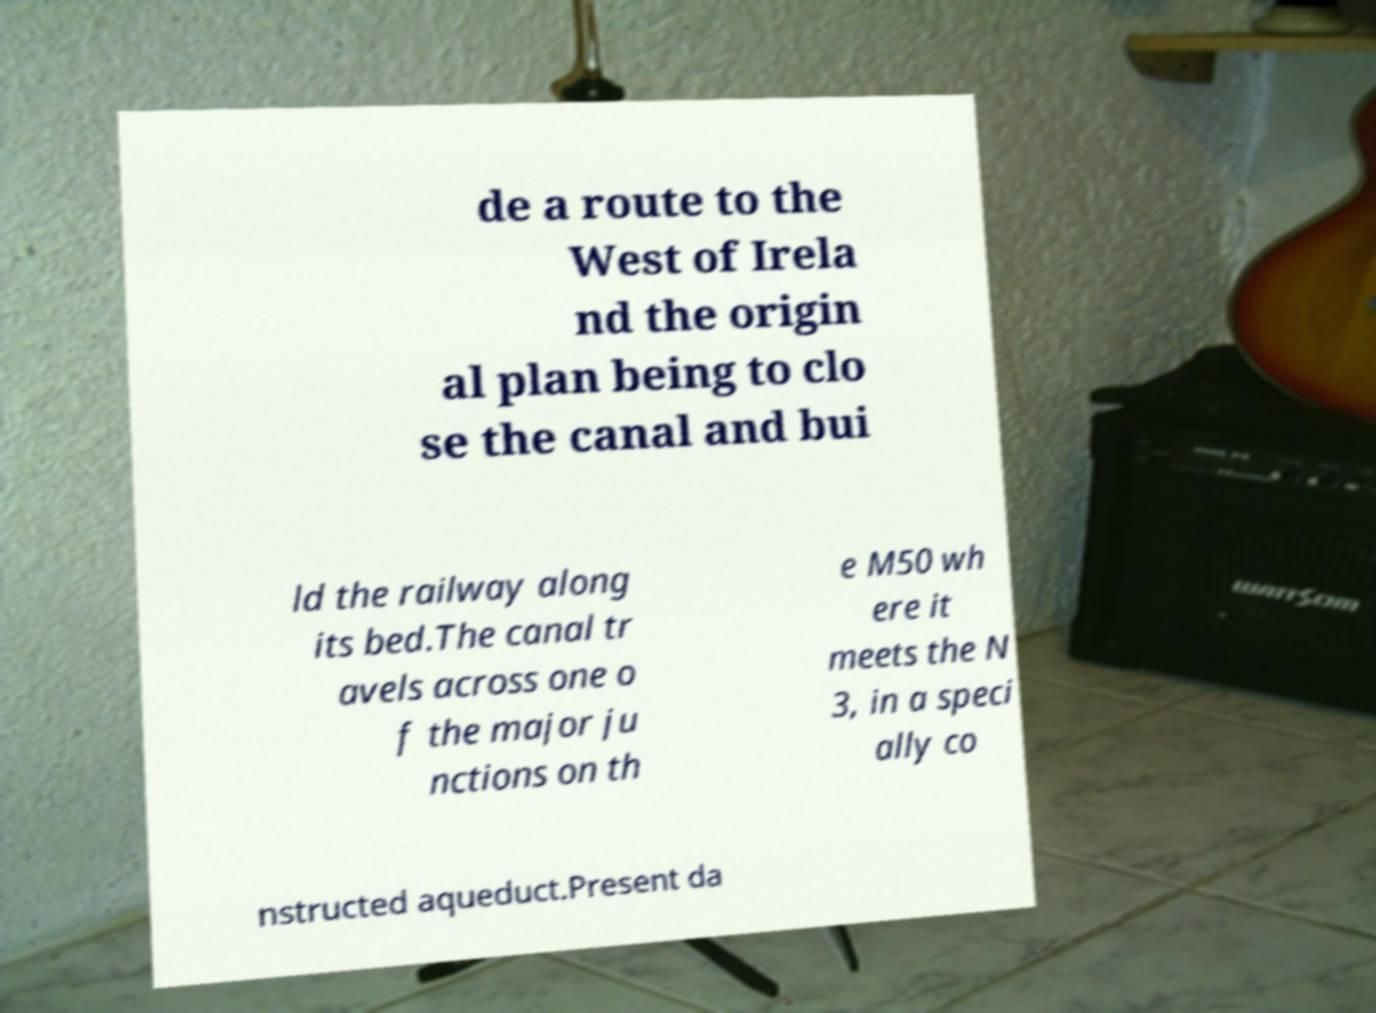Could you extract and type out the text from this image? de a route to the West of Irela nd the origin al plan being to clo se the canal and bui ld the railway along its bed.The canal tr avels across one o f the major ju nctions on th e M50 wh ere it meets the N 3, in a speci ally co nstructed aqueduct.Present da 